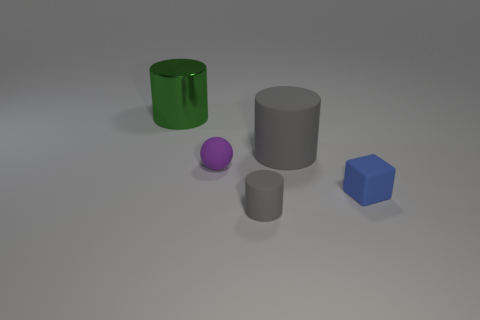Subtract all red cylinders. Subtract all purple balls. How many cylinders are left? 3 Add 1 small blocks. How many objects exist? 6 Subtract all cubes. How many objects are left? 4 Add 3 matte blocks. How many matte blocks are left? 4 Add 2 small brown spheres. How many small brown spheres exist? 2 Subtract 1 purple balls. How many objects are left? 4 Subtract all cubes. Subtract all red cubes. How many objects are left? 4 